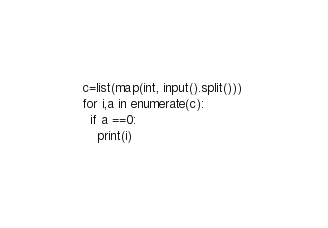<code> <loc_0><loc_0><loc_500><loc_500><_Python_>c=list(map(int, input().split())) 
for i,a in enumerate(c):
  if a ==0:
    print(i)</code> 